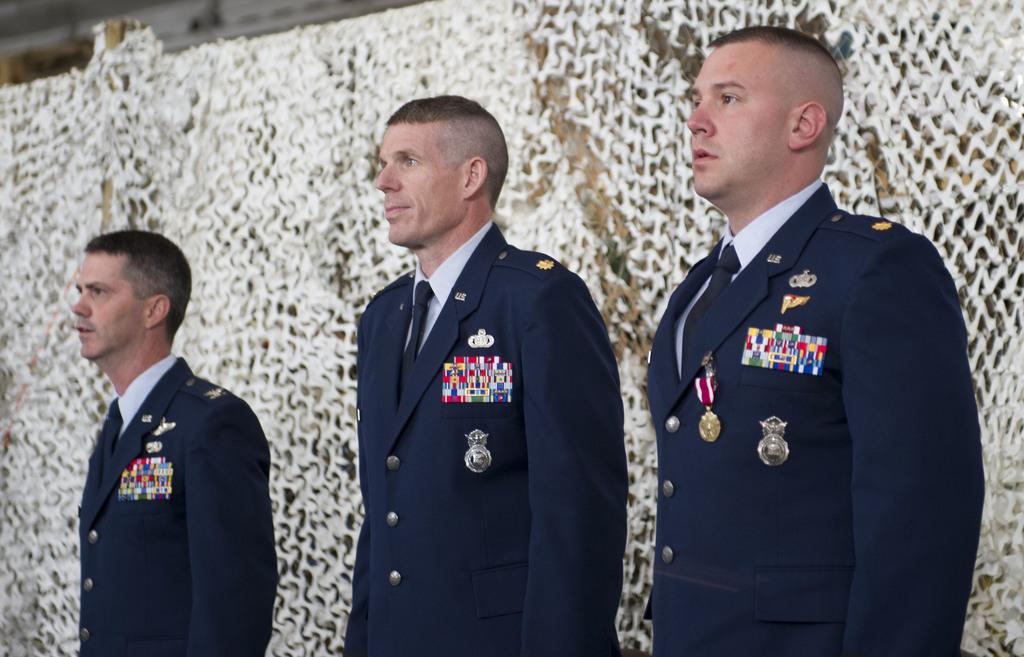How many people are in the image? There are three persons in the center of the image. What are the people wearing? The persons are wearing uniforms. What are the people doing in the image? The persons are standing. What color objects can be seen in the background of the image? There are white color objects in the background of the image. What else can be seen in the background of the image? There are other objects visible in the background of the image. What type of music can be heard playing in the background of the image? There is no music or sound present in the image, as it is a still photograph. 